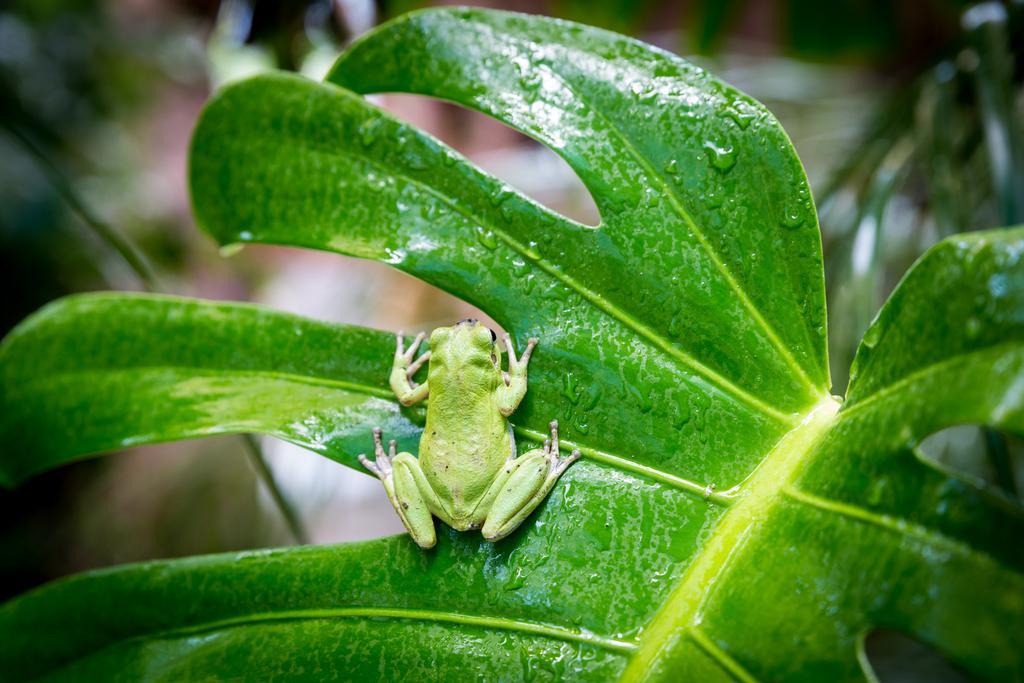Please provide a concise description of this image. In this picture there is a green frog who is standing on the leaf. On the right there is a plant. 